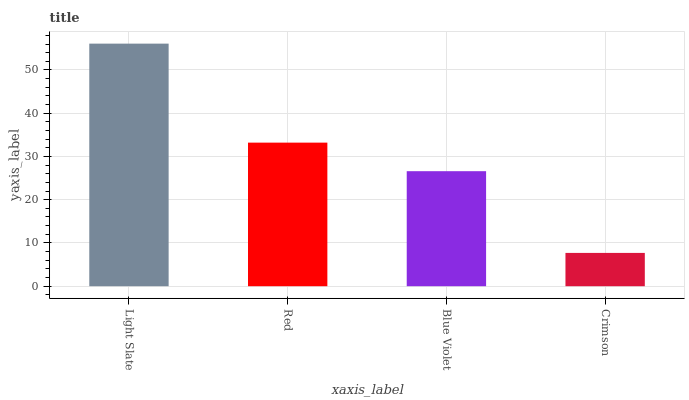Is Crimson the minimum?
Answer yes or no. Yes. Is Light Slate the maximum?
Answer yes or no. Yes. Is Red the minimum?
Answer yes or no. No. Is Red the maximum?
Answer yes or no. No. Is Light Slate greater than Red?
Answer yes or no. Yes. Is Red less than Light Slate?
Answer yes or no. Yes. Is Red greater than Light Slate?
Answer yes or no. No. Is Light Slate less than Red?
Answer yes or no. No. Is Red the high median?
Answer yes or no. Yes. Is Blue Violet the low median?
Answer yes or no. Yes. Is Light Slate the high median?
Answer yes or no. No. Is Crimson the low median?
Answer yes or no. No. 